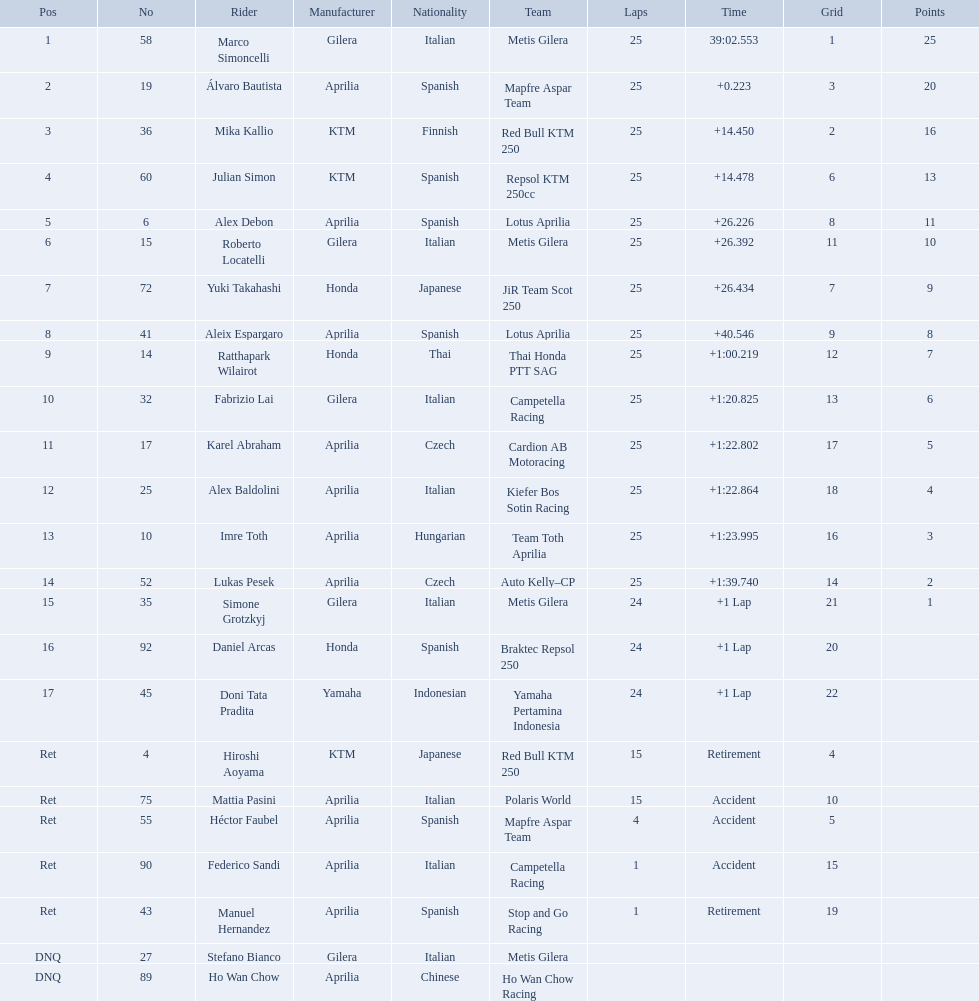How many laps did hiroshi aoyama perform? 15. How many laps did marco simoncelli perform? 25. Who performed more laps out of hiroshi aoyama and marco 
simoncelli? Marco Simoncelli. Who were all of the riders? Marco Simoncelli, Álvaro Bautista, Mika Kallio, Julian Simon, Alex Debon, Roberto Locatelli, Yuki Takahashi, Aleix Espargaro, Ratthapark Wilairot, Fabrizio Lai, Karel Abraham, Alex Baldolini, Imre Toth, Lukas Pesek, Simone Grotzkyj, Daniel Arcas, Doni Tata Pradita, Hiroshi Aoyama, Mattia Pasini, Héctor Faubel, Federico Sandi, Manuel Hernandez, Stefano Bianco, Ho Wan Chow. How many laps did they complete? 25, 25, 25, 25, 25, 25, 25, 25, 25, 25, 25, 25, 25, 25, 24, 24, 24, 15, 15, 4, 1, 1, , . Between marco simoncelli and hiroshi aoyama, who had more laps? Marco Simoncelli. What player number is marked #1 for the australian motorcycle grand prix? 58. Who is the rider that represents the #58 in the australian motorcycle grand prix? Marco Simoncelli. What was the fastest overall time? 39:02.553. Who does this time belong to? Marco Simoncelli. 